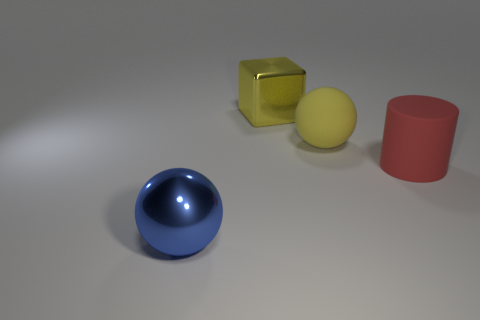There is another large thing that is made of the same material as the big blue object; what is its color?
Provide a succinct answer. Yellow. There is a sphere that is on the left side of the big yellow object in front of the large metallic thing behind the rubber sphere; what is its size?
Give a very brief answer. Large. Is the number of blue metal balls less than the number of small cyan rubber things?
Your response must be concise. No. What color is the matte object that is the same shape as the blue shiny thing?
Your response must be concise. Yellow. There is a red rubber thing that is to the right of the ball that is on the left side of the large yellow shiny block; are there any blue metallic spheres that are in front of it?
Offer a very short reply. Yes. Does the big blue object have the same shape as the big yellow shiny object?
Provide a succinct answer. No. Are there fewer large blue objects that are right of the yellow metallic block than big cubes?
Provide a short and direct response. Yes. There is a large rubber object that is to the right of the sphere behind the cylinder that is to the right of the big yellow metal cube; what is its color?
Ensure brevity in your answer.  Red. What number of metallic things are either large brown balls or big red cylinders?
Your answer should be very brief. 0. Does the yellow matte sphere have the same size as the blue object?
Your answer should be compact. Yes. 